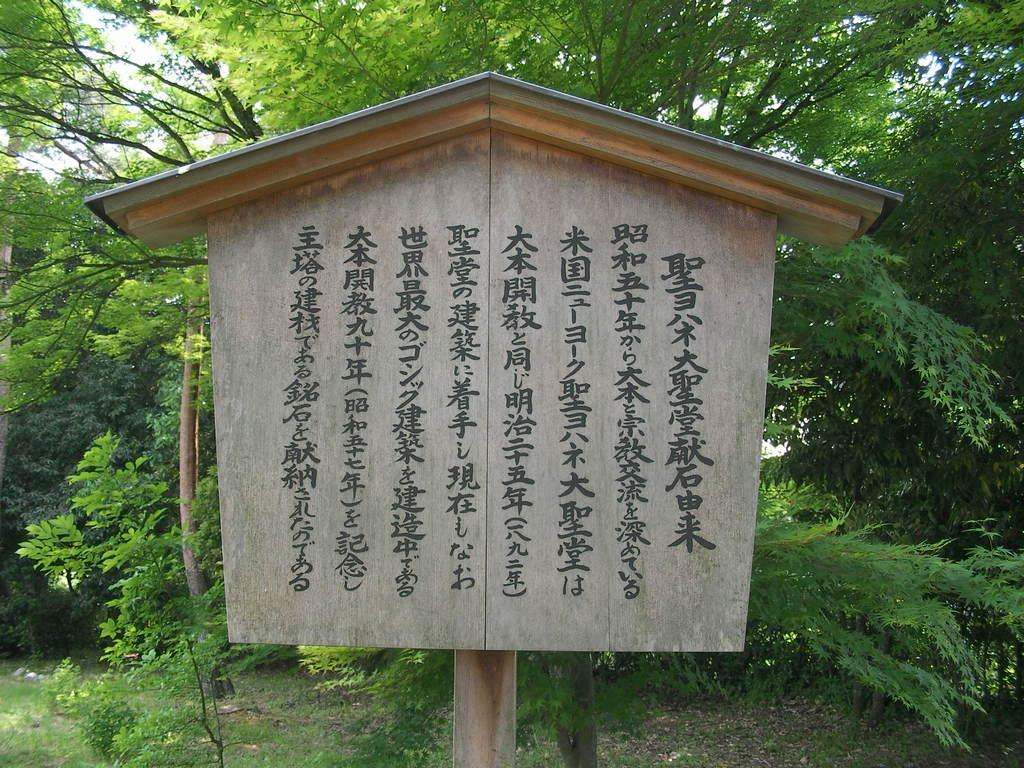What is the main structure in the image? There is a wooden pole in the image with a board attached to it. What is the purpose of the board? The board has text on it, which suggests it might be a sign or notice. What is above the wooden pole and board? There is a roof in the image. What can be seen in the background behind the board? There are trees visible behind the board. What type of treatment is being offered in the lunchroom depicted in the image? There is no lunchroom or treatment being depicted in the image; it features a wooden pole with a board attached to it, a roof, and trees in the background. How many spiders are visible on the board in the image? There are no spiders visible on the board in the image. 